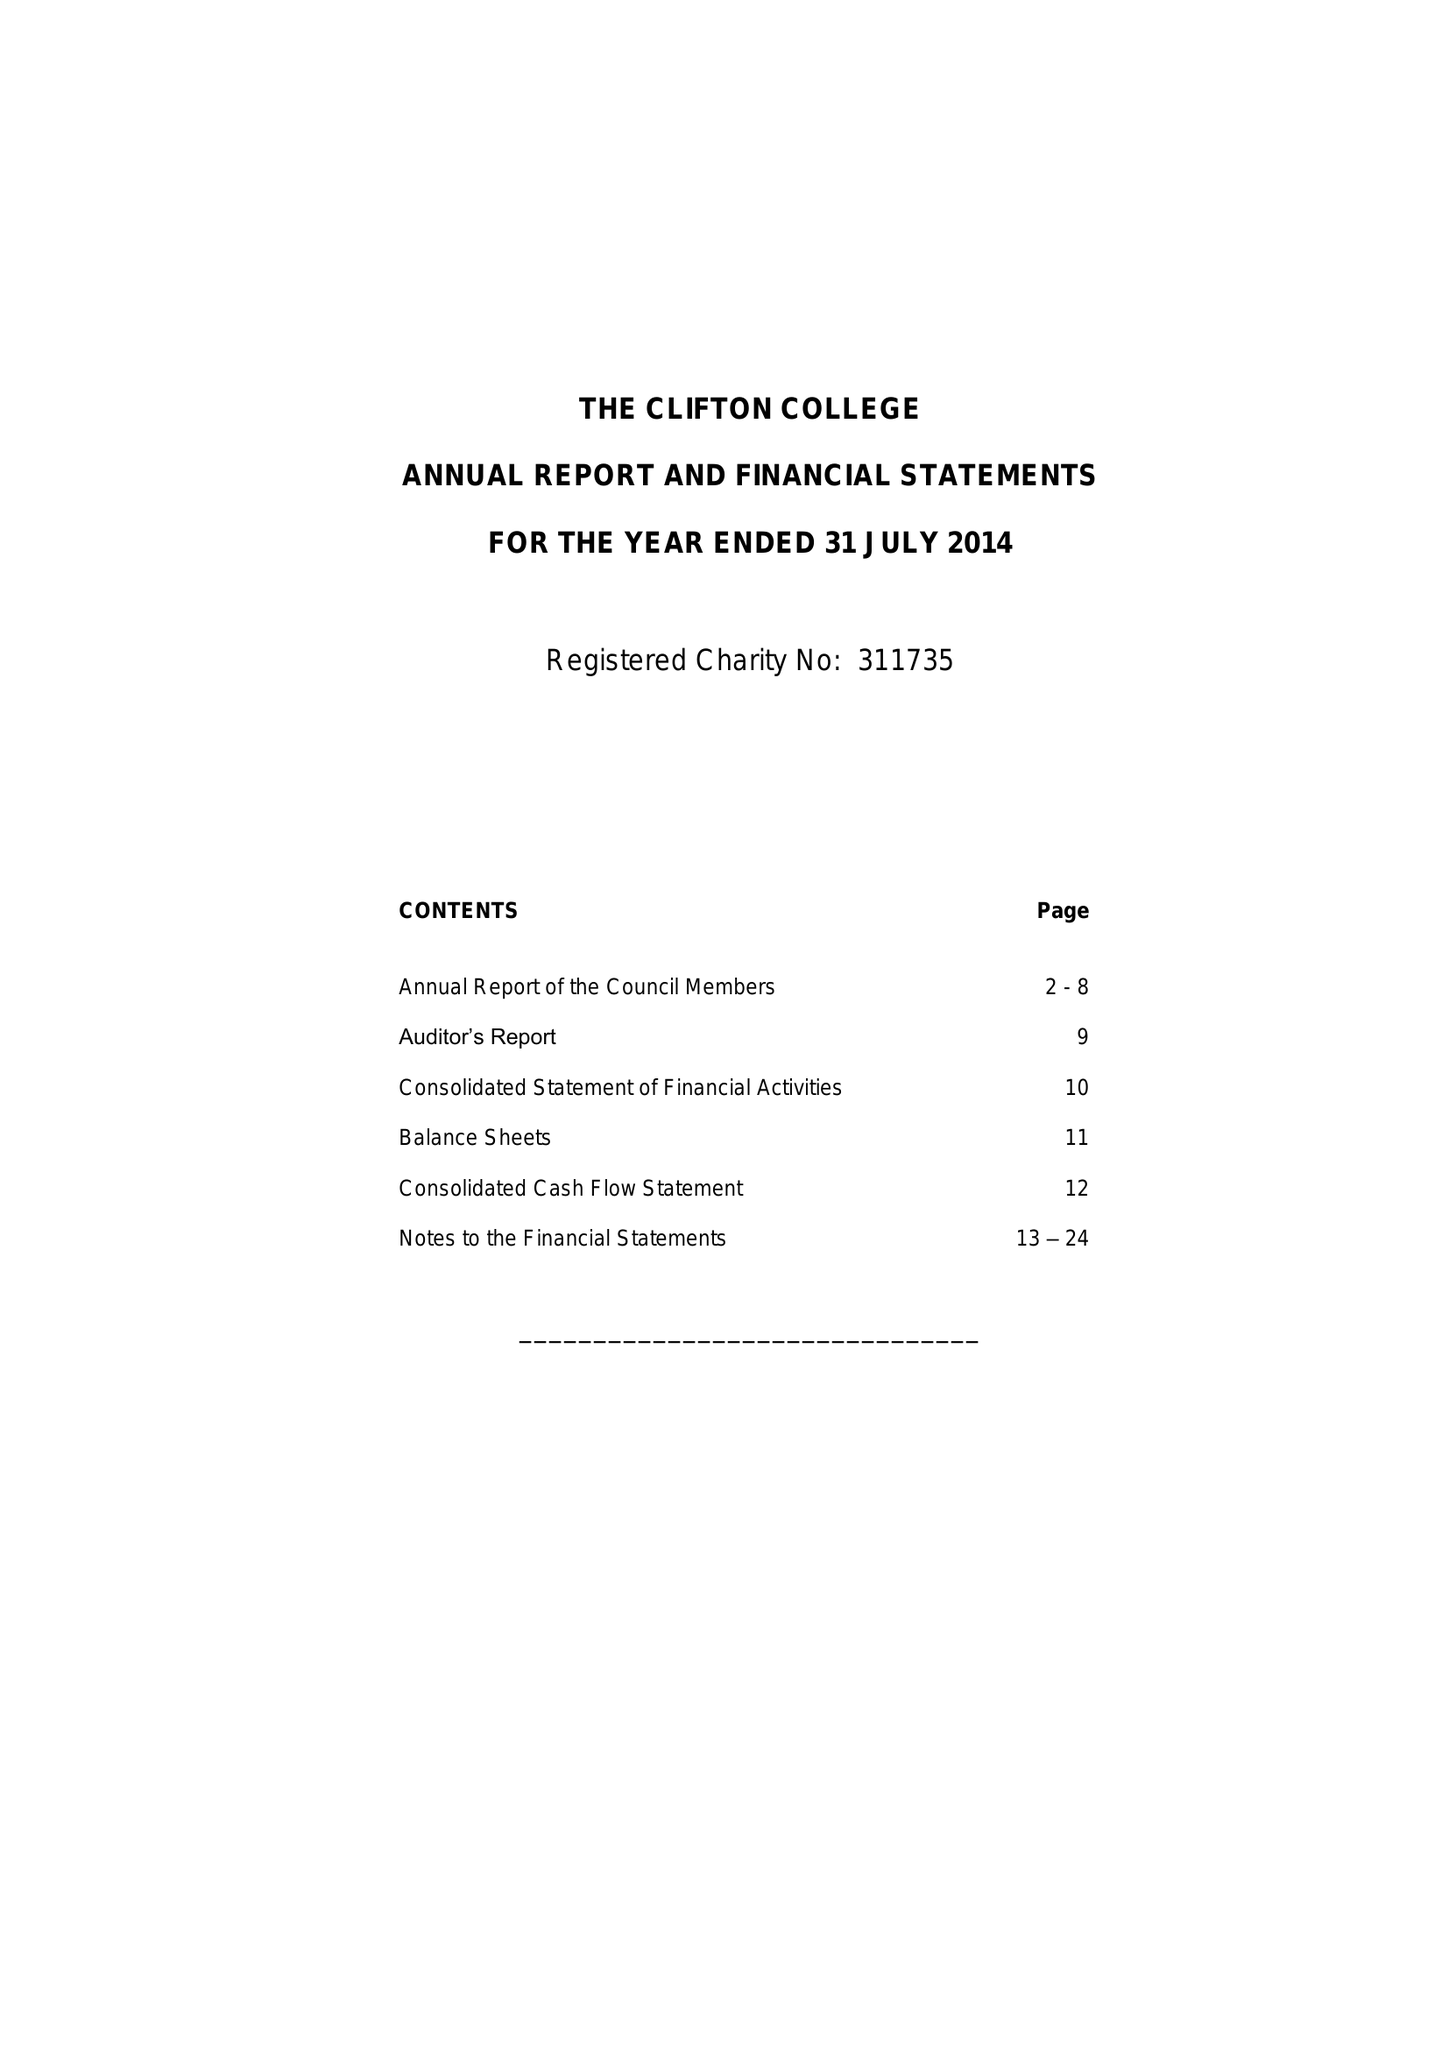What is the value for the report_date?
Answer the question using a single word or phrase. 2014-07-31 